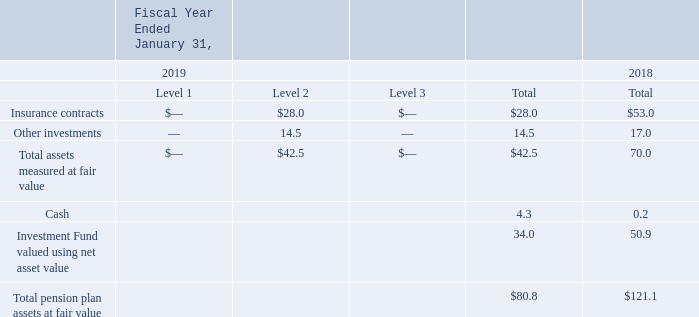Defined Benefit Pension Plan Assets
The investments of the plans are managed by insurance companies or third-party investment managers selected by Autodesk's Trustees, consistent with regulations or market practice of the country where the assets are invested. Investments managed by qualified insurance companies or third-party investment managers under standard contracts follow local regulations, and Autodesk is not actively involved in their investment strategies.
Defined benefit pension plan assets measured at fair value on a recurring basis consisted of the following investment categories at the end of each period as follows:
The insurance contracts in the preceding table represent the immediate cash surrender value of assets managed by qualified insurance companies. Autodesk does not have control over the target allocation or visibility of the investment strategies of those investments. Insurance contracts and investments held by insurance companies made up 35% and 44% of total plan assets as of January 31, 2019 and January 31, 2018, respectively.
The assets held in the investment fund in the preceding table are invested in a diversified growth fund actively managed by Russell Investments in association with Aon Hewitt. The objective of the fund is to generate capital appreciation on a longterm basis through a diversified portfolio of investments. The fund aims to deliver equity-like returns in the medium to long term with around two-thirds the volatility of equity markets. The fair value of the assets held in the investment fund are priced monthly at net asset value without restrictions on redemption.
Who manages Autodesk's pension plans? The investments of the plans are managed by insurance companies or third-party investment managers selected by autodesk's trustees, consistent with regulations or market practice of the country where the assets are invested. Where are the assets in the investment fund in the preceding table held? The assets held in the investment fund in the preceding table are invested in a diversified growth fund actively managed by russell investments in association with aon hewitt. How are the assets in the investment fund priced? The fair value of the assets held in the investment fund are priced monthly at net asset value without restrictions on redemption. What is the percentage change in total assets measured at fair value from 2018 to 2019?
Answer scale should be: percent. ((42.5-70)/70)
Answer: -39.29. How much of the total plan assets comprises cash in 2019?
Answer scale should be: percent. (4.3/80.8)
Answer: 5.32. What is the percentage change in insurance contracts between 2018 and 2019?
Answer scale should be: percent. (28-53)/53 
Answer: -47.17. 